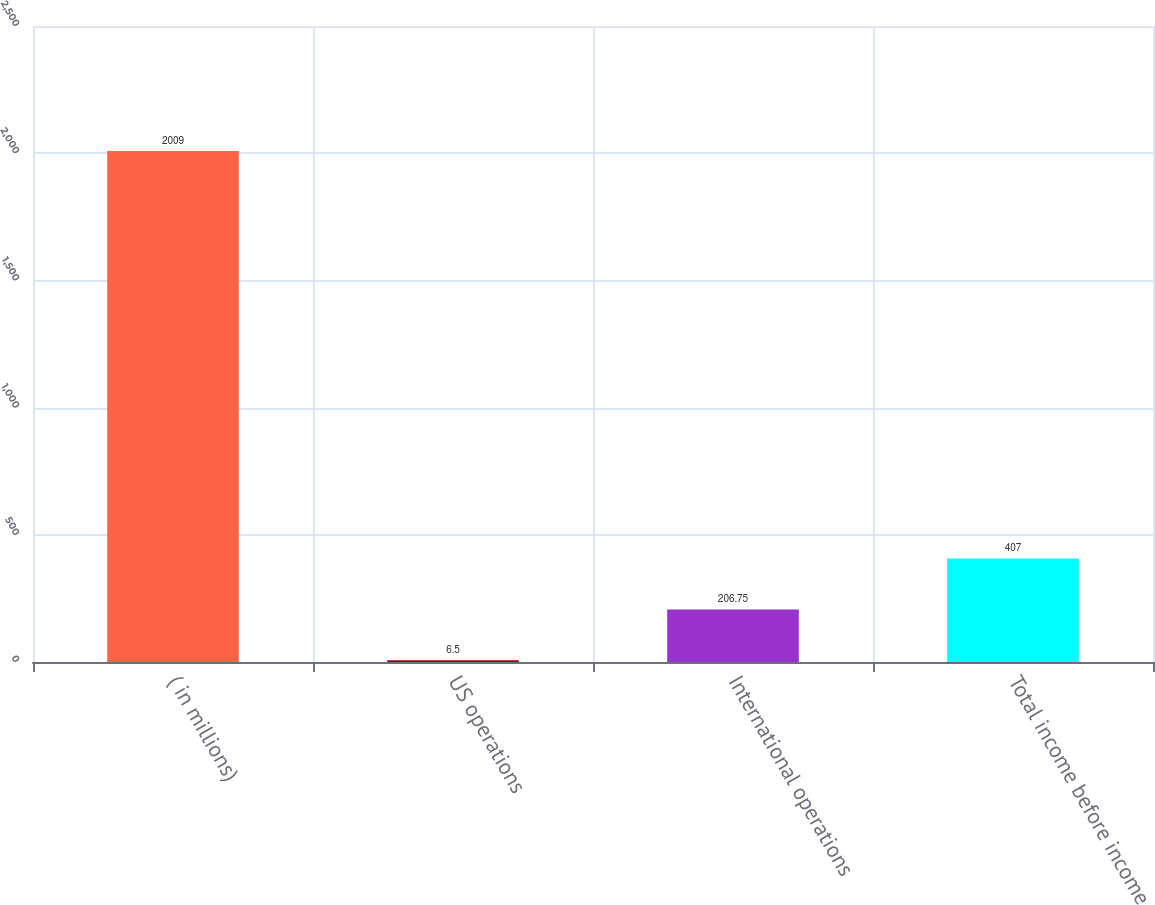Convert chart to OTSL. <chart><loc_0><loc_0><loc_500><loc_500><bar_chart><fcel>( in millions)<fcel>US operations<fcel>International operations<fcel>Total income before income<nl><fcel>2009<fcel>6.5<fcel>206.75<fcel>407<nl></chart> 